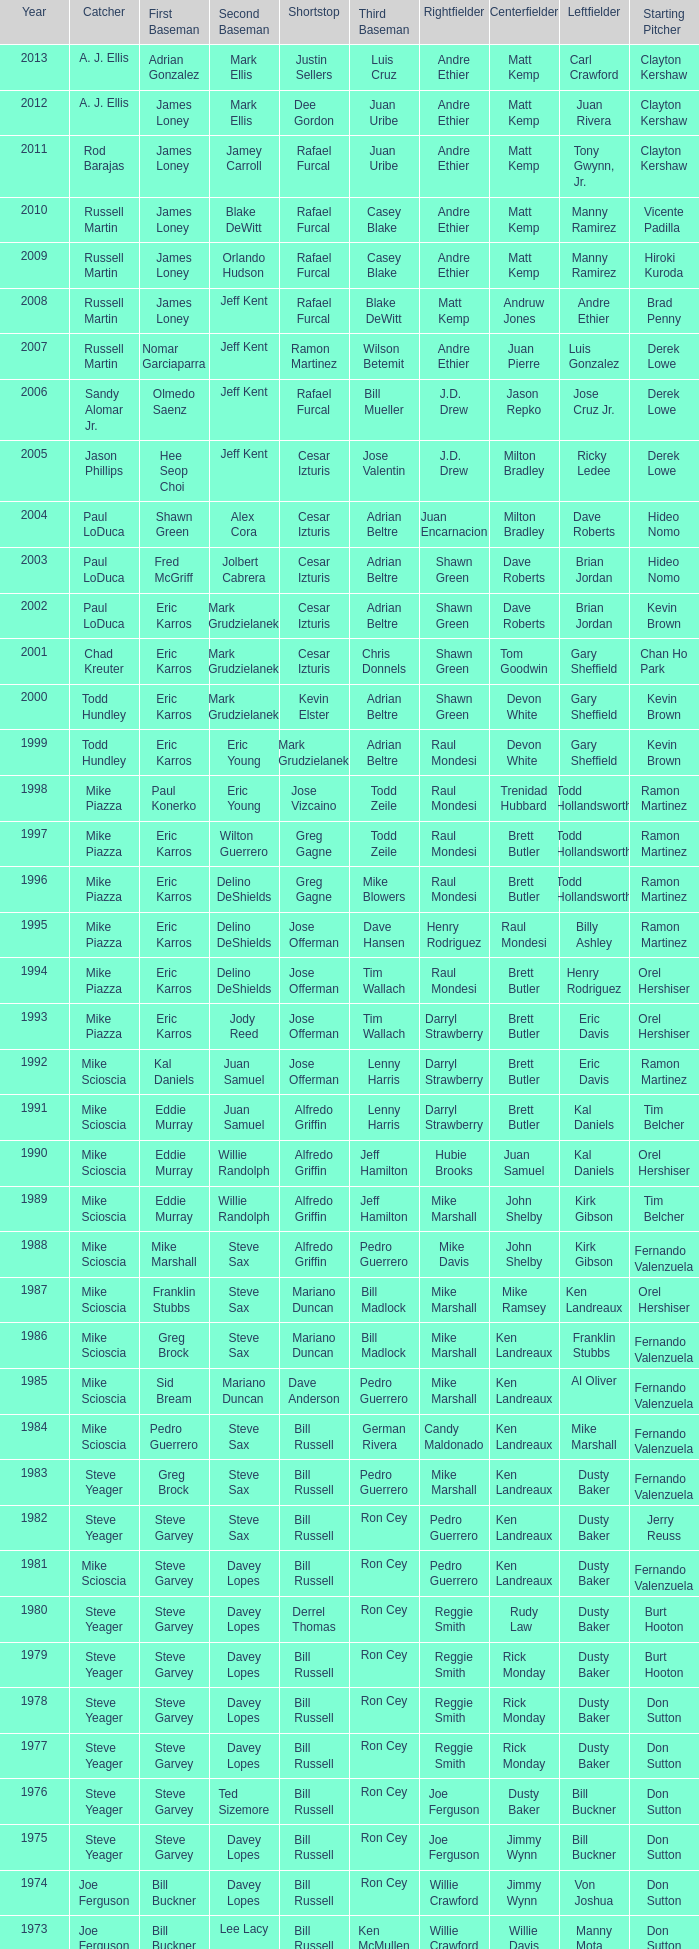Who was the SS when jim lefebvre was at 2nd, willie davis at CF, and don drysdale was the SP. Maury Wills. 